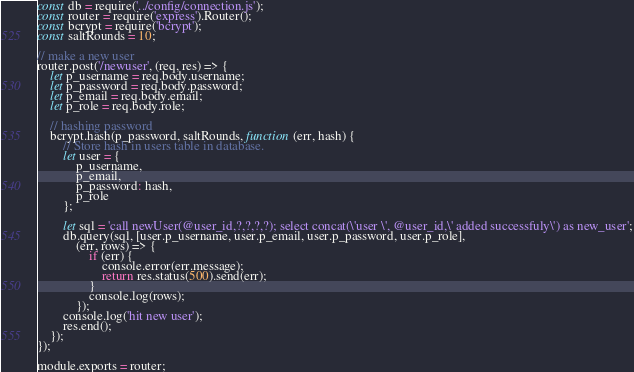<code> <loc_0><loc_0><loc_500><loc_500><_JavaScript_>const db = require('../config/connection.js');
const router = require('express').Router();
const bcrypt = require('bcrypt');
const saltRounds = 10;

// make a new user
router.post('/newuser', (req, res) => {
    let p_username = req.body.username;
    let p_password = req.body.password;
    let p_email = req.body.email;
    let p_role = req.body.role;

    // hashing password
    bcrypt.hash(p_password, saltRounds, function (err, hash) {
        // Store hash in users table in database.
        let user = {
            p_username,
            p_email,
            p_password: hash,
            p_role
        };

        let sql = 'call newUser(@user_id,?,?,?,?); select concat(\'user \', @user_id,\' added successfuly\') as new_user';
        db.query(sql, [user.p_username, user.p_email, user.p_password, user.p_role],
            (err, rows) => {
                if (err) {
                    console.error(err.message);
                    return res.status(500).send(err);
                }
                console.log(rows);
            });
        console.log('hit new user');
        res.end();
    });
});

module.exports = router;</code> 